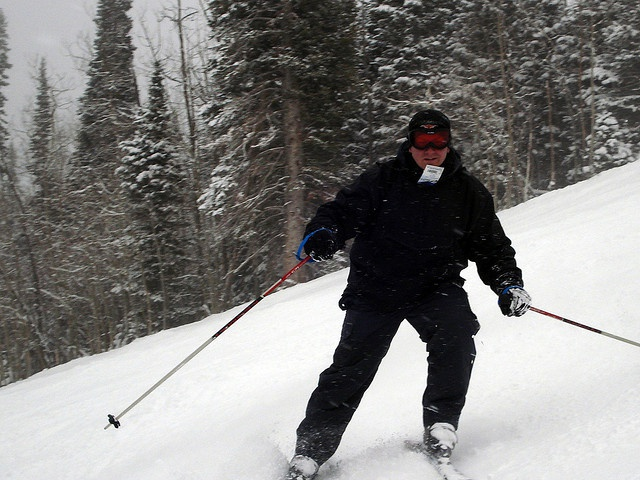Describe the objects in this image and their specific colors. I can see people in lightgray, black, gray, and darkgray tones and skis in lightgray, darkgray, and gray tones in this image. 